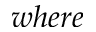<formula> <loc_0><loc_0><loc_500><loc_500>w h e r e</formula> 